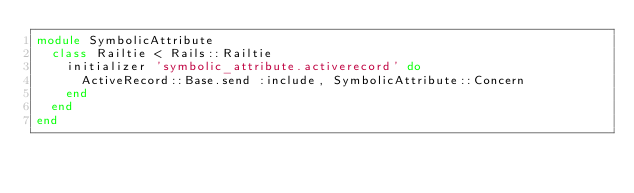<code> <loc_0><loc_0><loc_500><loc_500><_Ruby_>module SymbolicAttribute
  class Railtie < Rails::Railtie
    initializer 'symbolic_attribute.activerecord' do
      ActiveRecord::Base.send :include, SymbolicAttribute::Concern
    end
  end
end</code> 